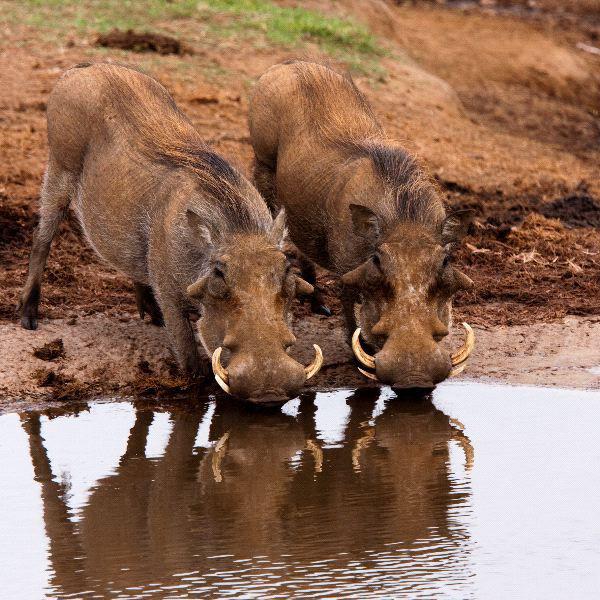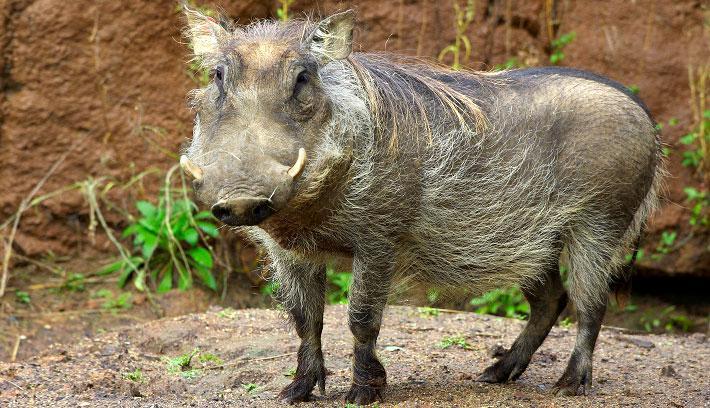The first image is the image on the left, the second image is the image on the right. For the images shown, is this caption "In one image there are at least two warthogs drinking out of a pond." true? Answer yes or no. Yes. The first image is the image on the left, the second image is the image on the right. Examine the images to the left and right. Is the description "the left image has at most 2 wartgogs" accurate? Answer yes or no. Yes. 